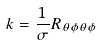Convert formula to latex. <formula><loc_0><loc_0><loc_500><loc_500>k = \frac { 1 } { \sigma } R _ { \theta \phi \theta \phi }</formula> 